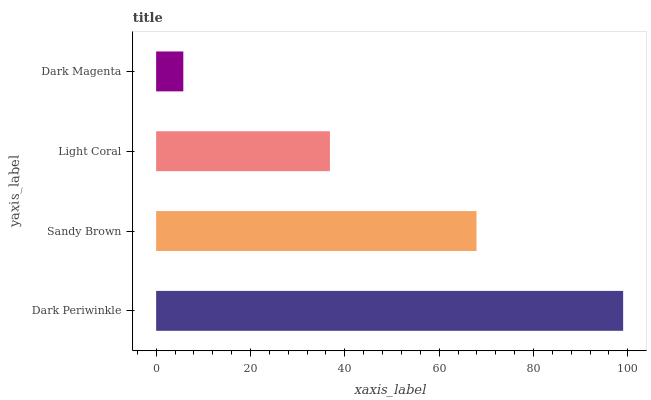Is Dark Magenta the minimum?
Answer yes or no. Yes. Is Dark Periwinkle the maximum?
Answer yes or no. Yes. Is Sandy Brown the minimum?
Answer yes or no. No. Is Sandy Brown the maximum?
Answer yes or no. No. Is Dark Periwinkle greater than Sandy Brown?
Answer yes or no. Yes. Is Sandy Brown less than Dark Periwinkle?
Answer yes or no. Yes. Is Sandy Brown greater than Dark Periwinkle?
Answer yes or no. No. Is Dark Periwinkle less than Sandy Brown?
Answer yes or no. No. Is Sandy Brown the high median?
Answer yes or no. Yes. Is Light Coral the low median?
Answer yes or no. Yes. Is Dark Magenta the high median?
Answer yes or no. No. Is Dark Periwinkle the low median?
Answer yes or no. No. 